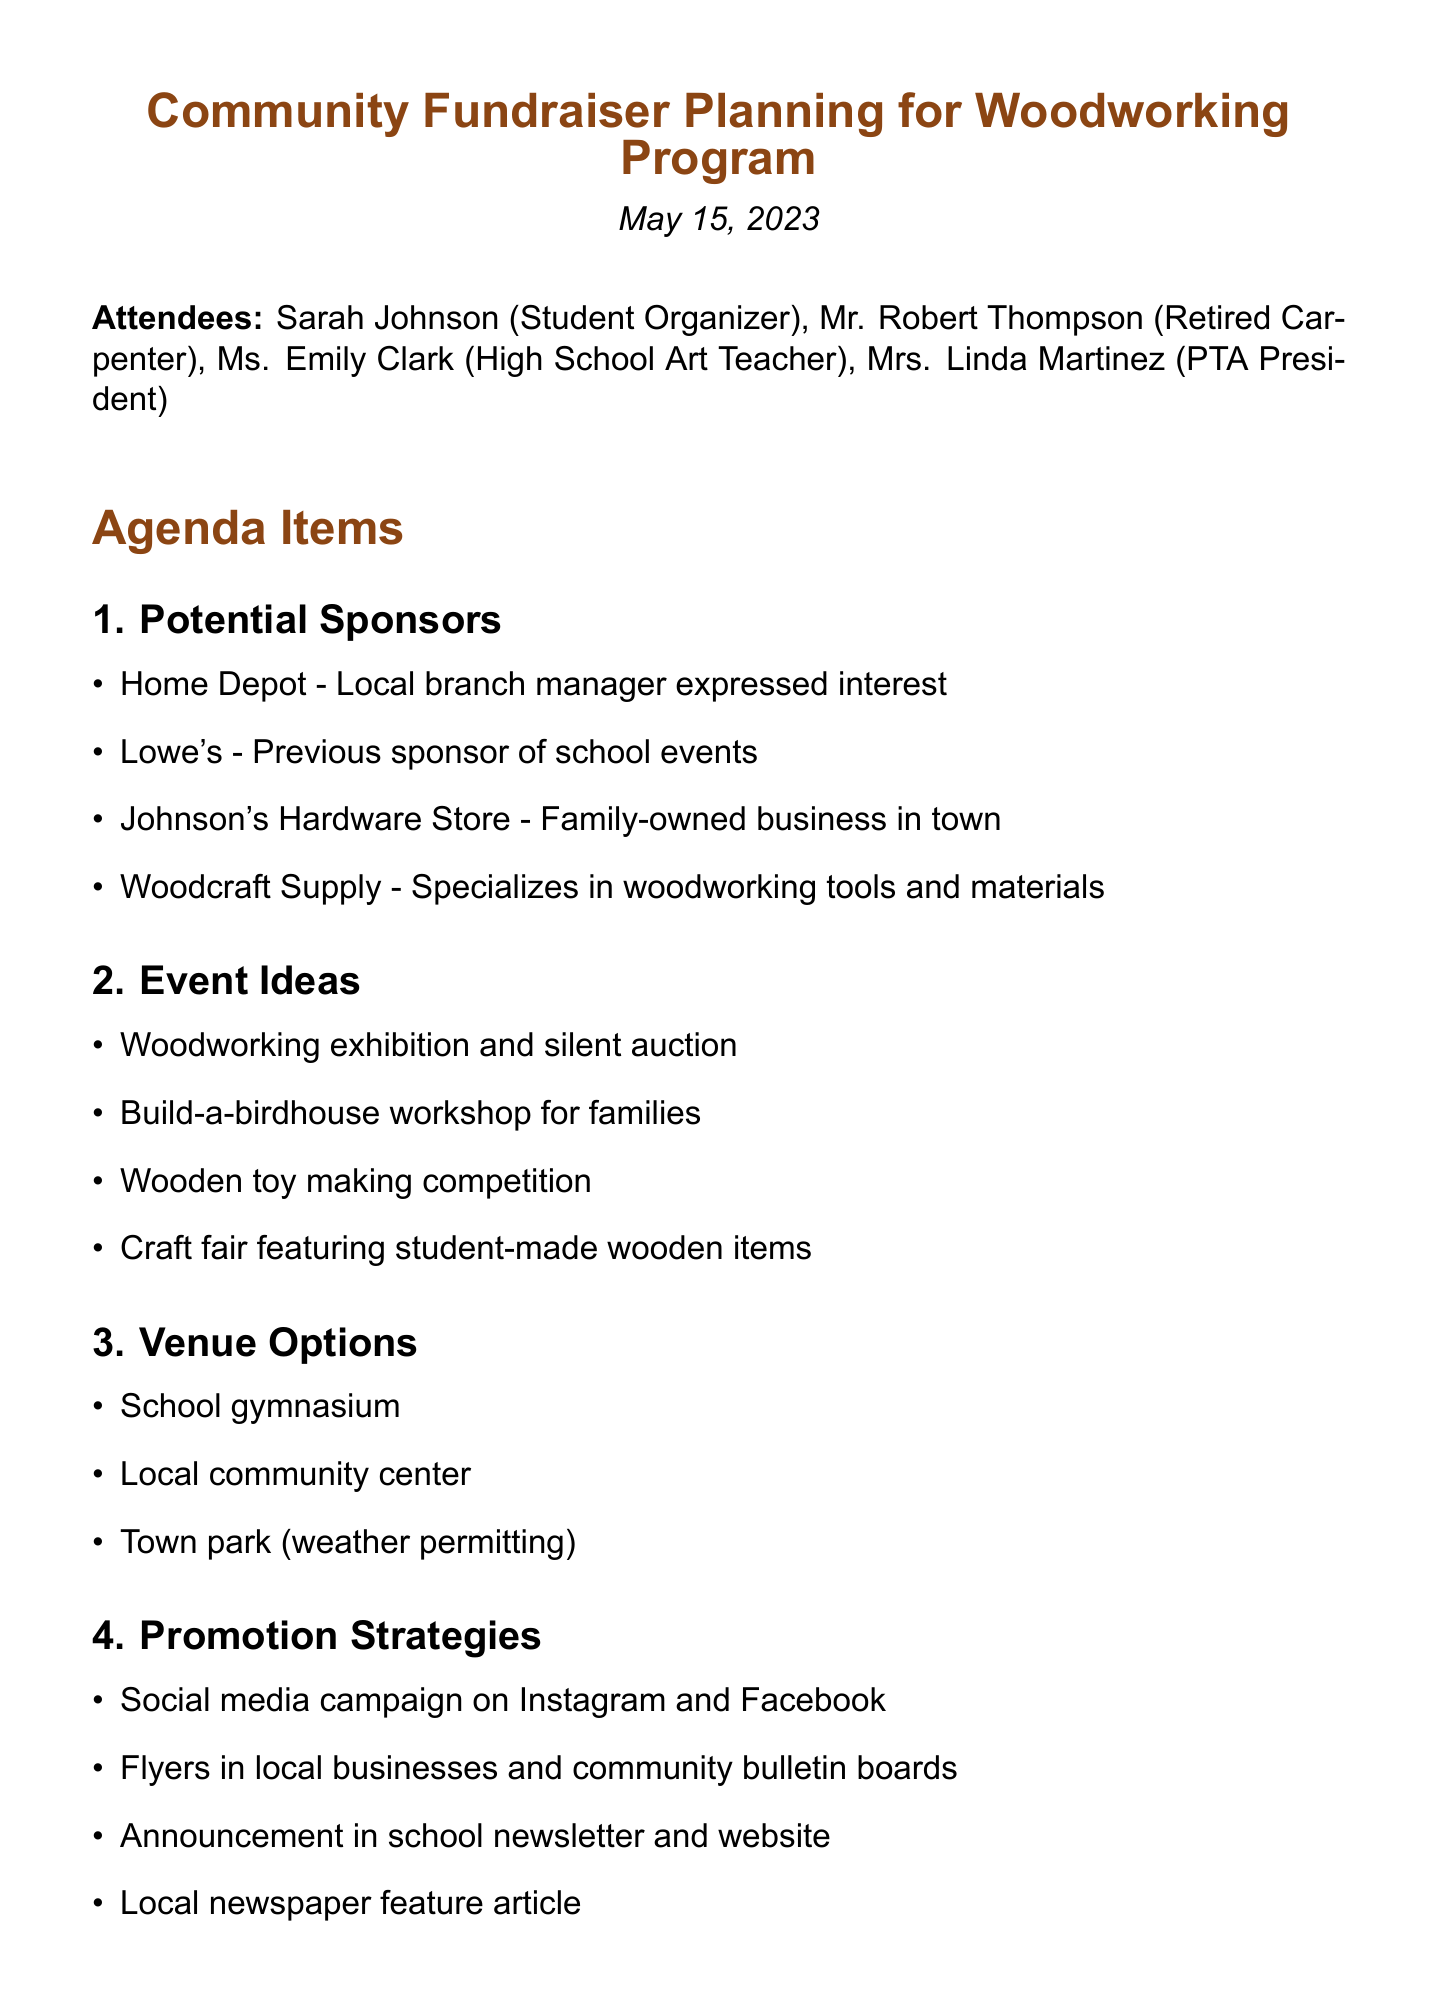What is the title of the meeting? The title of the meeting is provided at the beginning of the document.
Answer: Community Fundraiser Planning for Woodworking Program Who is the Student Organizer? The document lists attendees, including the role of each.
Answer: Sarah Johnson What date was the meeting held? The meeting's date is specified in the document.
Answer: May 15, 2023 Which store specializes in woodworking tools? This information is found under the "Potential Sponsors" section.
Answer: Woodcraft Supply What is one event idea proposed for the fundraiser? The document lists various event ideas under the "Event Ideas" agenda item.
Answer: Build-a-birdhouse workshop for families Where is one of the proposed venue options? The venue options are listed in the document, detailing locations for the event.
Answer: School gymnasium What promotion strategy involves social media? The promotion strategies detail how to reach the community, including online platforms.
Answer: Social media campaign on Instagram and Facebook What is the first step listed in "Next Steps"? The "Next Steps" section gives a sequence of actions to take following the meeting.
Answer: Assign team members to contact potential sponsors 